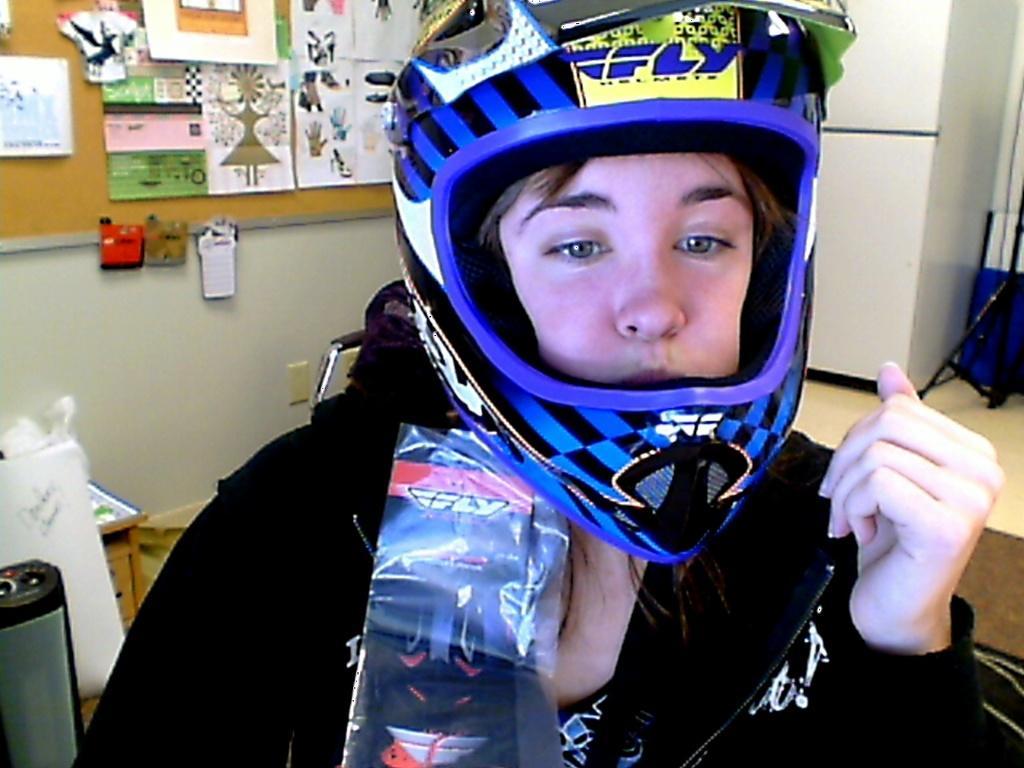Please provide a concise description of this image. In this picture we can see a person wore a helmet and at the back of this person we can see a stand, chair, posters on a board and this board is on the wall and some objects. 